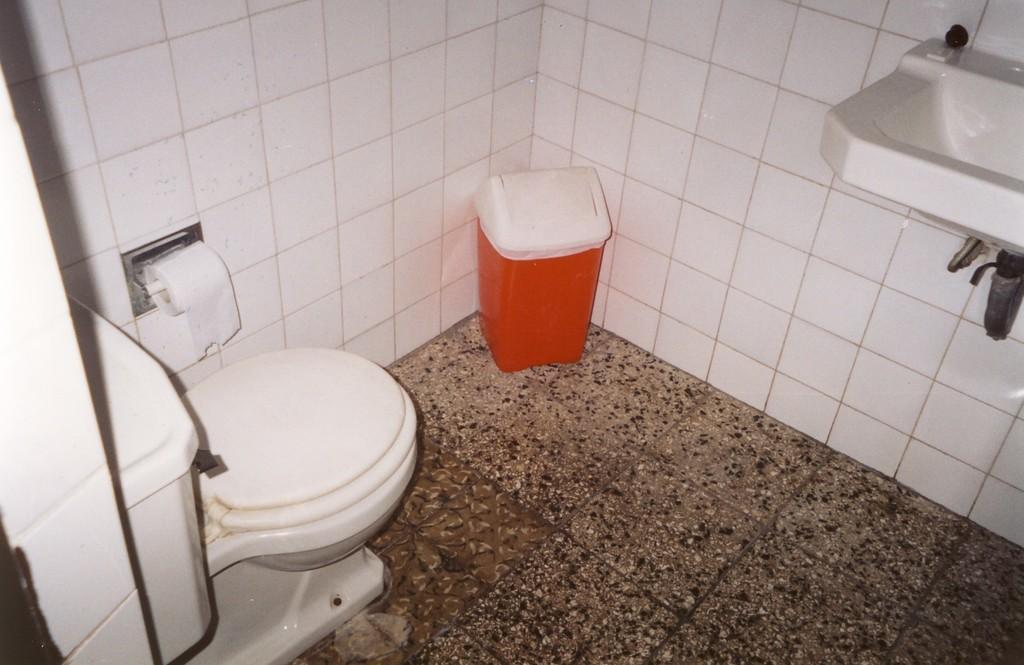How would you summarize this image in a sentence or two? In the foreground of this image, on the right top, there is a sink. A dustbin, in the corner. A toilet bowl and the tank on the left side and there is a tissue roll to the wall. On the bottom, there is the floor. 